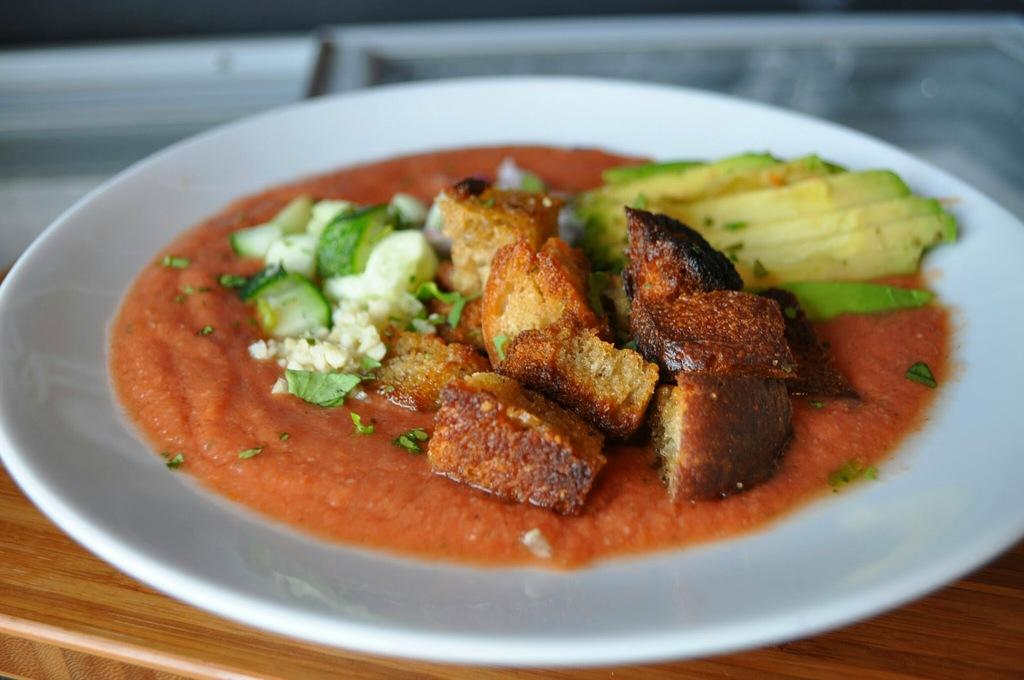What is on the plate that is visible in the image? The plate has food items on it. Where is the plate located in the image? The plate is placed on a table. Can you describe the background of the image? There is a blurry object in the background of the image. What type of trucks can be seen driving through the underwear in the image? There are no trucks or underwear present in the image; it features a white plate with food items on it placed on a table, and a blurry object in the background. 